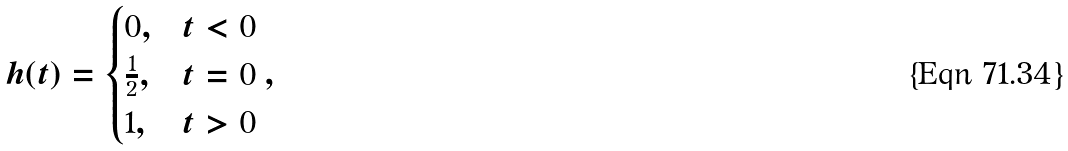<formula> <loc_0><loc_0><loc_500><loc_500>h ( t ) = \begin{cases} 0 , & t < 0 \\ \frac { 1 } { 2 } , & t = 0 \\ 1 , & t > 0 \end{cases} ,</formula> 